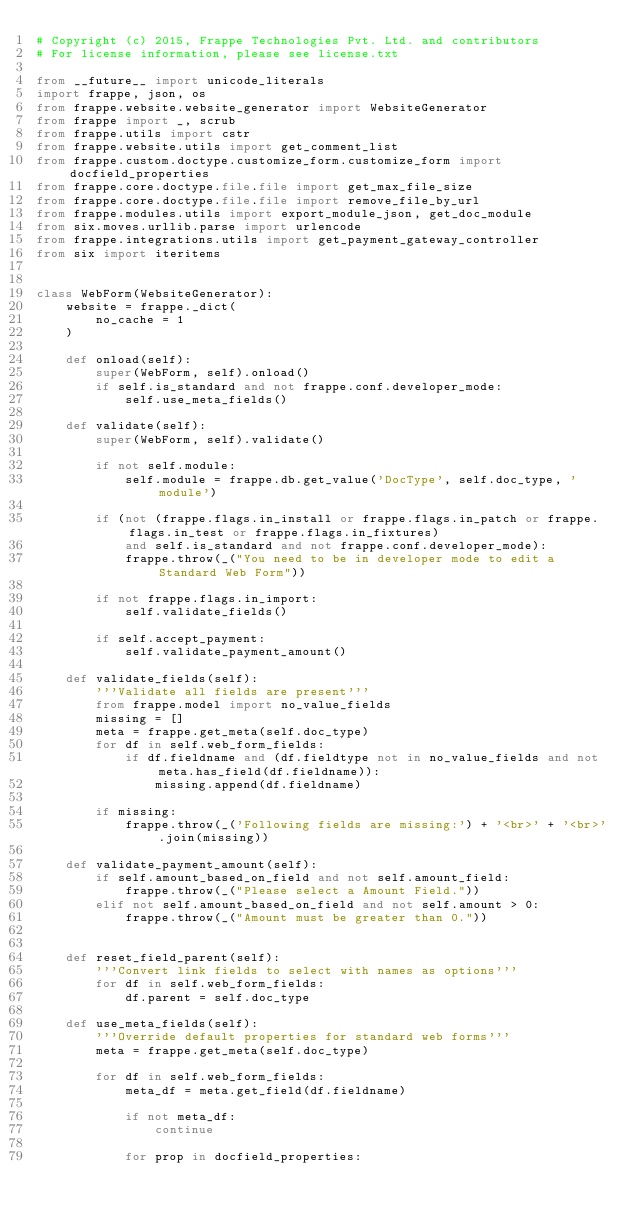<code> <loc_0><loc_0><loc_500><loc_500><_Python_># Copyright (c) 2015, Frappe Technologies Pvt. Ltd. and contributors
# For license information, please see license.txt

from __future__ import unicode_literals
import frappe, json, os
from frappe.website.website_generator import WebsiteGenerator
from frappe import _, scrub
from frappe.utils import cstr
from frappe.website.utils import get_comment_list
from frappe.custom.doctype.customize_form.customize_form import docfield_properties
from frappe.core.doctype.file.file import get_max_file_size
from frappe.core.doctype.file.file import remove_file_by_url
from frappe.modules.utils import export_module_json, get_doc_module
from six.moves.urllib.parse import urlencode
from frappe.integrations.utils import get_payment_gateway_controller
from six import iteritems


class WebForm(WebsiteGenerator):
	website = frappe._dict(
		no_cache = 1
	)

	def onload(self):
		super(WebForm, self).onload()
		if self.is_standard and not frappe.conf.developer_mode:
			self.use_meta_fields()

	def validate(self):
		super(WebForm, self).validate()

		if not self.module:
			self.module = frappe.db.get_value('DocType', self.doc_type, 'module')

		if (not (frappe.flags.in_install or frappe.flags.in_patch or frappe.flags.in_test or frappe.flags.in_fixtures)
			and self.is_standard and not frappe.conf.developer_mode):
			frappe.throw(_("You need to be in developer mode to edit a Standard Web Form"))

		if not frappe.flags.in_import:
			self.validate_fields()

		if self.accept_payment:
			self.validate_payment_amount()

	def validate_fields(self):
		'''Validate all fields are present'''
		from frappe.model import no_value_fields
		missing = []
		meta = frappe.get_meta(self.doc_type)
		for df in self.web_form_fields:
			if df.fieldname and (df.fieldtype not in no_value_fields and not meta.has_field(df.fieldname)):
				missing.append(df.fieldname)

		if missing:
			frappe.throw(_('Following fields are missing:') + '<br>' + '<br>'.join(missing))

	def validate_payment_amount(self):
		if self.amount_based_on_field and not self.amount_field:
			frappe.throw(_("Please select a Amount Field."))
		elif not self.amount_based_on_field and not self.amount > 0:
			frappe.throw(_("Amount must be greater than 0."))


	def reset_field_parent(self):
		'''Convert link fields to select with names as options'''
		for df in self.web_form_fields:
			df.parent = self.doc_type

	def use_meta_fields(self):
		'''Override default properties for standard web forms'''
		meta = frappe.get_meta(self.doc_type)

		for df in self.web_form_fields:
			meta_df = meta.get_field(df.fieldname)

			if not meta_df:
				continue

			for prop in docfield_properties:</code> 